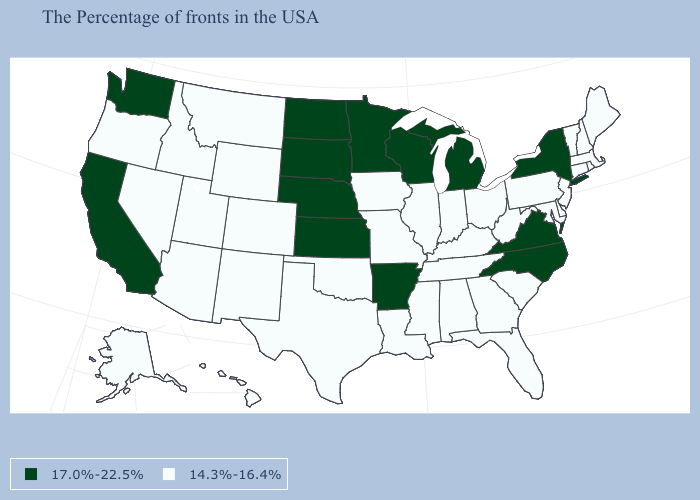Does the first symbol in the legend represent the smallest category?
Quick response, please. No. Does the first symbol in the legend represent the smallest category?
Keep it brief. No. Does California have the highest value in the West?
Quick response, please. Yes. Name the states that have a value in the range 17.0%-22.5%?
Keep it brief. New York, Virginia, North Carolina, Michigan, Wisconsin, Arkansas, Minnesota, Kansas, Nebraska, South Dakota, North Dakota, California, Washington. What is the value of Tennessee?
Short answer required. 14.3%-16.4%. Which states have the highest value in the USA?
Give a very brief answer. New York, Virginia, North Carolina, Michigan, Wisconsin, Arkansas, Minnesota, Kansas, Nebraska, South Dakota, North Dakota, California, Washington. What is the value of Kentucky?
Quick response, please. 14.3%-16.4%. What is the value of Alaska?
Answer briefly. 14.3%-16.4%. Name the states that have a value in the range 17.0%-22.5%?
Write a very short answer. New York, Virginia, North Carolina, Michigan, Wisconsin, Arkansas, Minnesota, Kansas, Nebraska, South Dakota, North Dakota, California, Washington. What is the lowest value in the MidWest?
Concise answer only. 14.3%-16.4%. What is the value of Louisiana?
Write a very short answer. 14.3%-16.4%. Among the states that border Vermont , does New York have the highest value?
Short answer required. Yes. Which states have the lowest value in the USA?
Give a very brief answer. Maine, Massachusetts, Rhode Island, New Hampshire, Vermont, Connecticut, New Jersey, Delaware, Maryland, Pennsylvania, South Carolina, West Virginia, Ohio, Florida, Georgia, Kentucky, Indiana, Alabama, Tennessee, Illinois, Mississippi, Louisiana, Missouri, Iowa, Oklahoma, Texas, Wyoming, Colorado, New Mexico, Utah, Montana, Arizona, Idaho, Nevada, Oregon, Alaska, Hawaii. Name the states that have a value in the range 14.3%-16.4%?
Short answer required. Maine, Massachusetts, Rhode Island, New Hampshire, Vermont, Connecticut, New Jersey, Delaware, Maryland, Pennsylvania, South Carolina, West Virginia, Ohio, Florida, Georgia, Kentucky, Indiana, Alabama, Tennessee, Illinois, Mississippi, Louisiana, Missouri, Iowa, Oklahoma, Texas, Wyoming, Colorado, New Mexico, Utah, Montana, Arizona, Idaho, Nevada, Oregon, Alaska, Hawaii. Does New York have the highest value in the Northeast?
Quick response, please. Yes. 